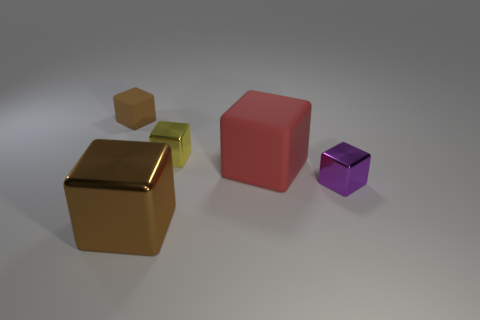Subtract 3 blocks. How many blocks are left? 2 Subtract all rubber blocks. How many blocks are left? 3 Add 2 large green rubber balls. How many objects exist? 7 Subtract all red blocks. How many blocks are left? 4 Subtract all green blocks. Subtract all green cylinders. How many blocks are left? 5 Add 1 small objects. How many small objects exist? 4 Subtract 0 green cubes. How many objects are left? 5 Subtract all tiny brown metal cubes. Subtract all matte cubes. How many objects are left? 3 Add 3 cubes. How many cubes are left? 8 